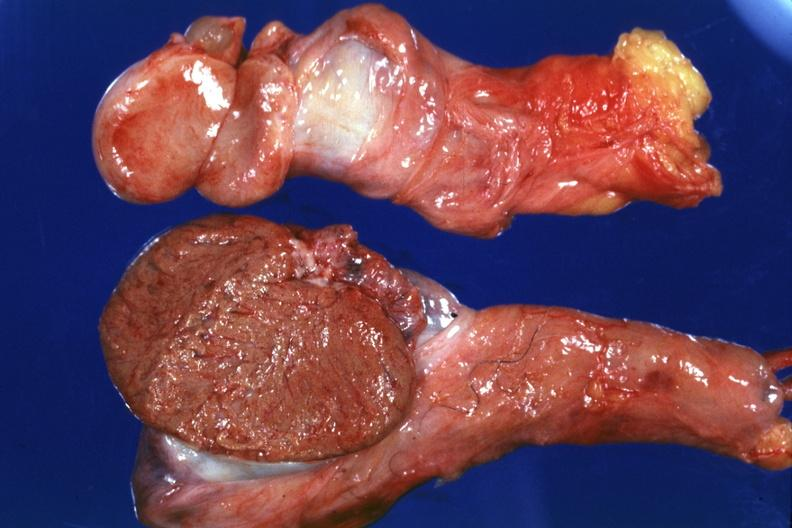s fibrosis mumps present?
Answer the question using a single word or phrase. Yes 